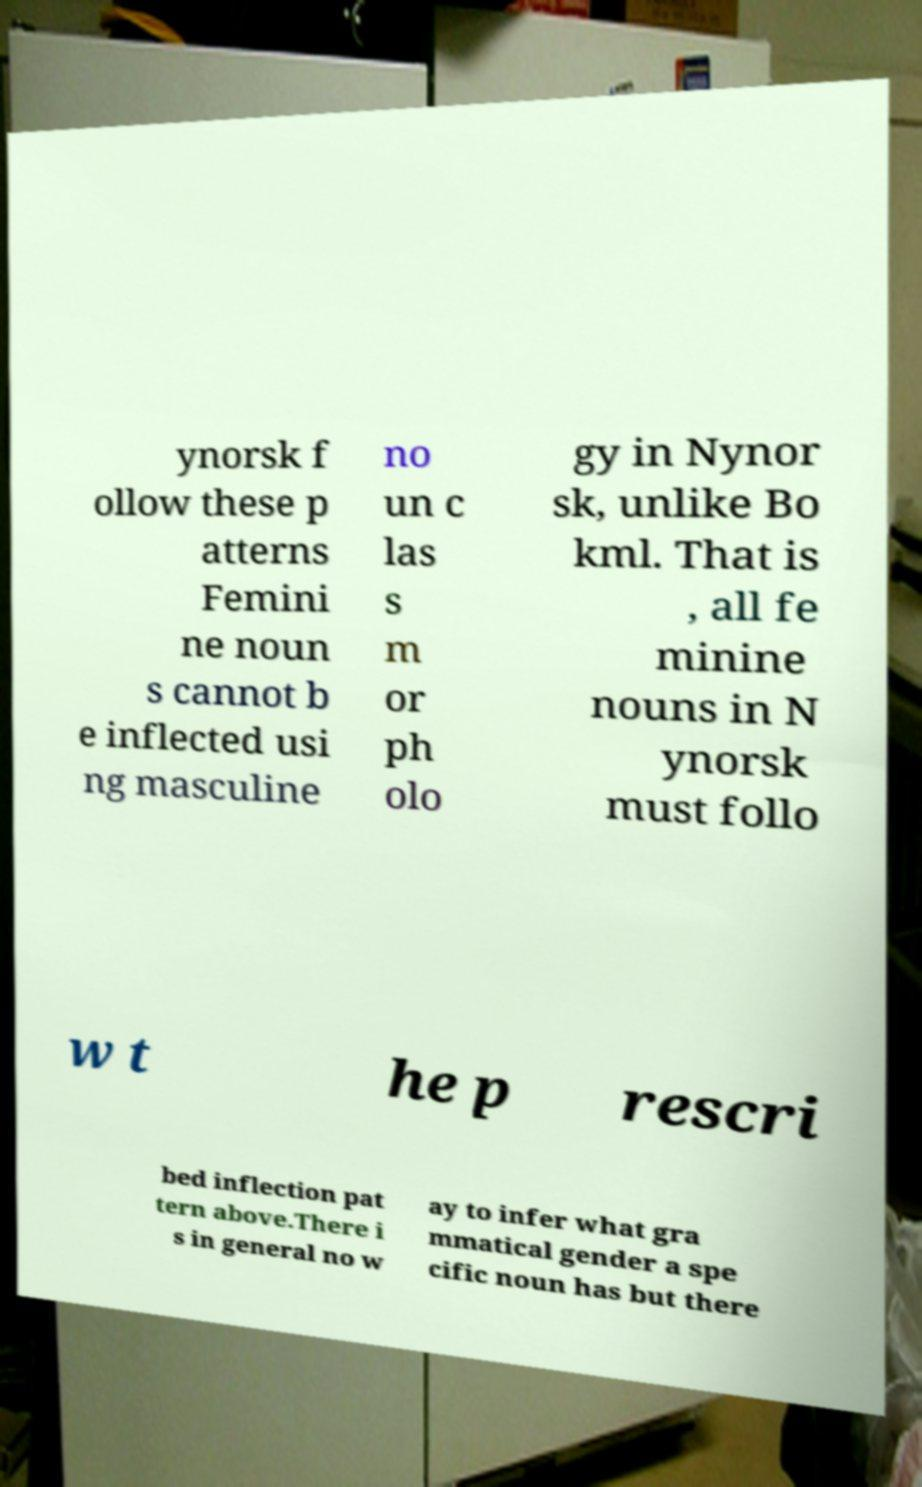For documentation purposes, I need the text within this image transcribed. Could you provide that? ynorsk f ollow these p atterns Femini ne noun s cannot b e inflected usi ng masculine no un c las s m or ph olo gy in Nynor sk, unlike Bo kml. That is , all fe minine nouns in N ynorsk must follo w t he p rescri bed inflection pat tern above.There i s in general no w ay to infer what gra mmatical gender a spe cific noun has but there 